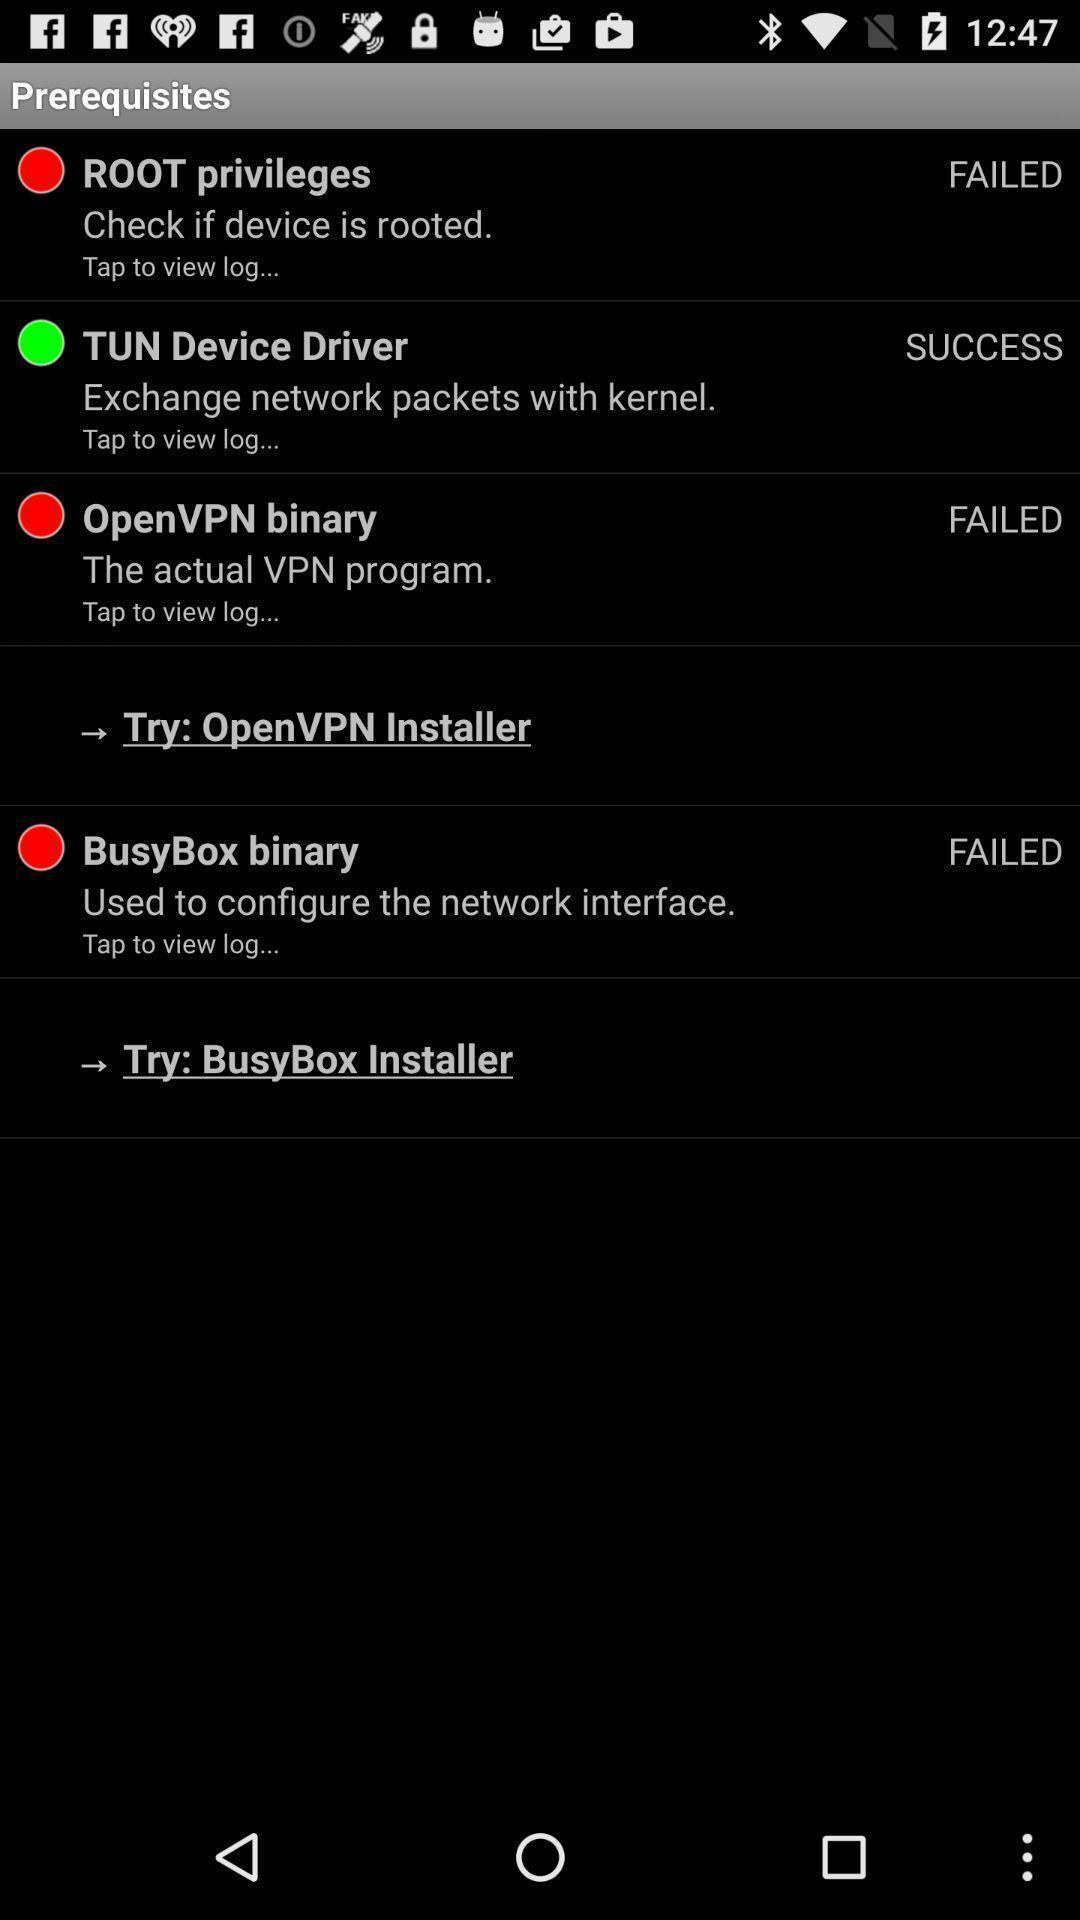Summarize the information in this screenshot. Screen displaying a list of prerequisites. 